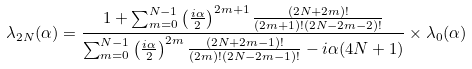Convert formula to latex. <formula><loc_0><loc_0><loc_500><loc_500>\lambda _ { 2 N } ( \alpha ) = { \frac { 1 + \sum _ { m = 0 } ^ { N - 1 } \left ( { \frac { i \alpha } { 2 } } \right ) ^ { 2 m + 1 } { \frac { ( 2 N + 2 m ) ! } { ( 2 m + 1 ) ! ( 2 N - 2 m - 2 ) ! } } } { \sum _ { m = 0 } ^ { N - 1 } \left ( { \frac { i \alpha } { 2 } } \right ) ^ { 2 m } { \frac { ( 2 N + 2 m - 1 ) ! } { ( 2 m ) ! ( 2 N - 2 m - 1 ) ! } } - i \alpha ( 4 N + 1 ) } } \times \lambda _ { 0 } ( \alpha )</formula> 